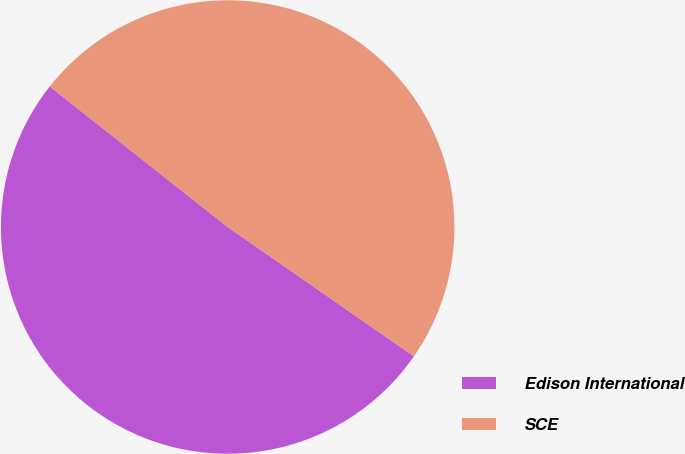Convert chart to OTSL. <chart><loc_0><loc_0><loc_500><loc_500><pie_chart><fcel>Edison International<fcel>SCE<nl><fcel>50.98%<fcel>49.02%<nl></chart> 